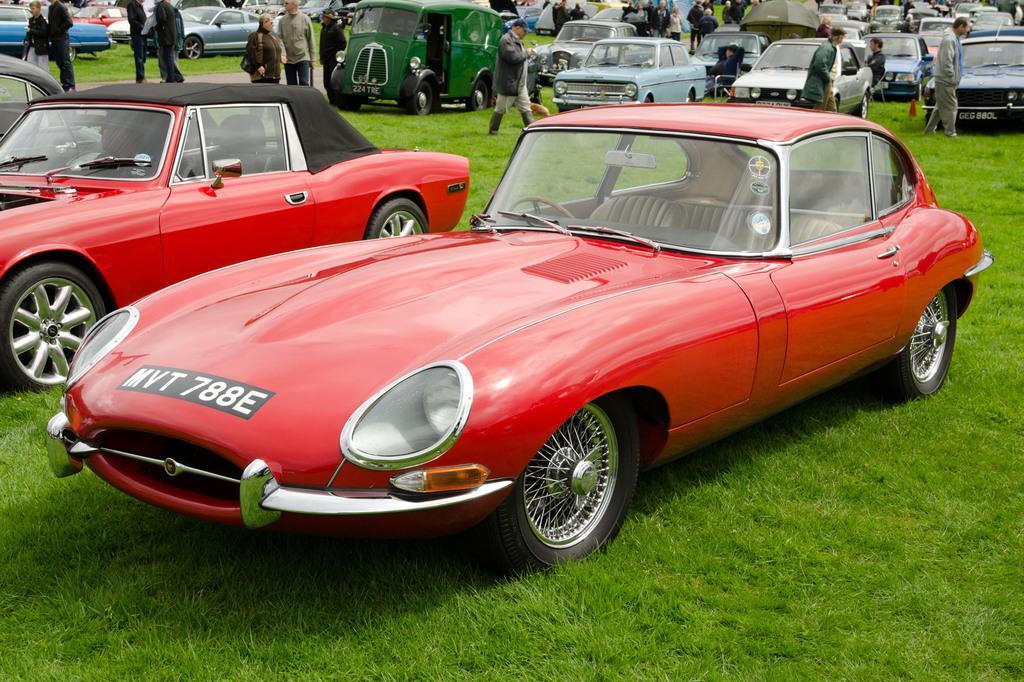Please provide a concise description of this image. In this image, we can see vehicles on the ground and there are people. 